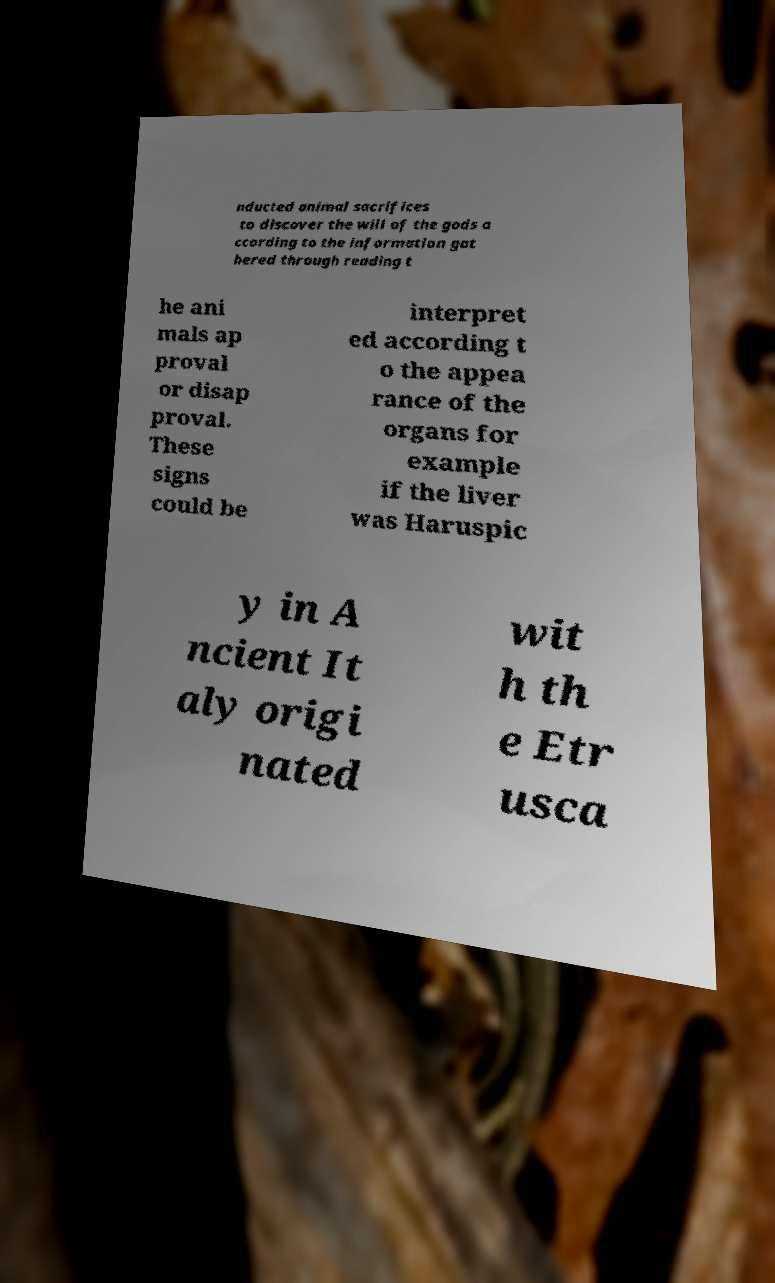Can you accurately transcribe the text from the provided image for me? nducted animal sacrifices to discover the will of the gods a ccording to the information gat hered through reading t he ani mals ap proval or disap proval. These signs could be interpret ed according t o the appea rance of the organs for example if the liver was Haruspic y in A ncient It aly origi nated wit h th e Etr usca 